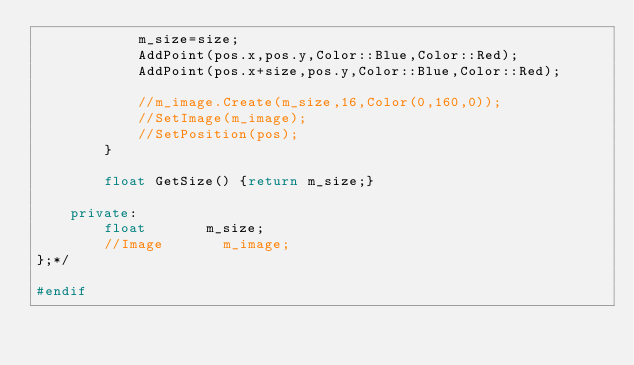<code> <loc_0><loc_0><loc_500><loc_500><_C++_>            m_size=size;
            AddPoint(pos.x,pos.y,Color::Blue,Color::Red);
            AddPoint(pos.x+size,pos.y,Color::Blue,Color::Red);

            //m_image.Create(m_size,16,Color(0,160,0));
            //SetImage(m_image);
            //SetPosition(pos);
        }

        float GetSize() {return m_size;}

    private:
        float       m_size;
        //Image       m_image;
};*/

#endif
</code> 